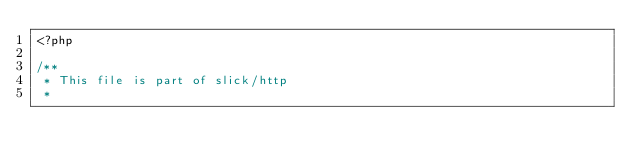<code> <loc_0><loc_0><loc_500><loc_500><_PHP_><?php

/**
 * This file is part of slick/http
 *</code> 